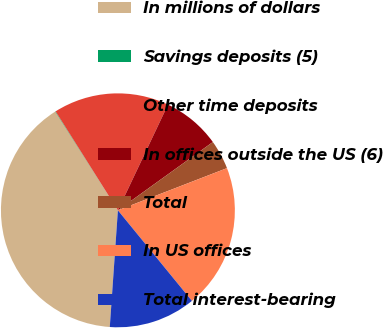Convert chart. <chart><loc_0><loc_0><loc_500><loc_500><pie_chart><fcel>In millions of dollars<fcel>Savings deposits (5)<fcel>Other time deposits<fcel>In offices outside the US (6)<fcel>Total<fcel>In US offices<fcel>Total interest-bearing<nl><fcel>39.89%<fcel>0.06%<fcel>15.99%<fcel>8.03%<fcel>4.05%<fcel>19.97%<fcel>12.01%<nl></chart> 